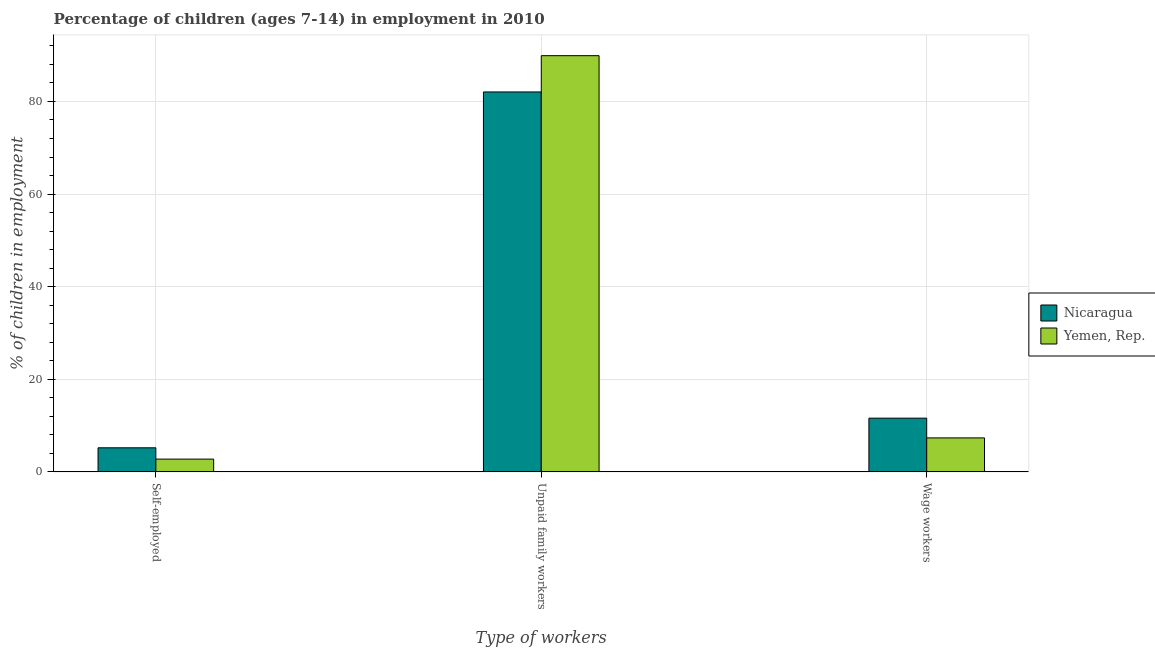How many different coloured bars are there?
Make the answer very short. 2. Are the number of bars per tick equal to the number of legend labels?
Offer a terse response. Yes. Are the number of bars on each tick of the X-axis equal?
Provide a short and direct response. Yes. How many bars are there on the 2nd tick from the left?
Provide a short and direct response. 2. How many bars are there on the 3rd tick from the right?
Offer a terse response. 2. What is the label of the 1st group of bars from the left?
Your answer should be very brief. Self-employed. What is the percentage of children employed as unpaid family workers in Nicaragua?
Your answer should be compact. 82.05. Across all countries, what is the maximum percentage of children employed as wage workers?
Your answer should be compact. 11.61. Across all countries, what is the minimum percentage of children employed as wage workers?
Keep it short and to the point. 7.35. In which country was the percentage of children employed as unpaid family workers maximum?
Offer a very short reply. Yemen, Rep. In which country was the percentage of self employed children minimum?
Make the answer very short. Yemen, Rep. What is the total percentage of children employed as wage workers in the graph?
Your response must be concise. 18.96. What is the difference between the percentage of children employed as unpaid family workers in Nicaragua and that in Yemen, Rep.?
Make the answer very short. -7.83. What is the difference between the percentage of children employed as unpaid family workers in Nicaragua and the percentage of self employed children in Yemen, Rep.?
Offer a very short reply. 79.28. What is the average percentage of self employed children per country?
Provide a short and direct response. 3.99. What is the difference between the percentage of children employed as wage workers and percentage of children employed as unpaid family workers in Nicaragua?
Keep it short and to the point. -70.44. What is the ratio of the percentage of children employed as wage workers in Nicaragua to that in Yemen, Rep.?
Make the answer very short. 1.58. Is the percentage of children employed as unpaid family workers in Nicaragua less than that in Yemen, Rep.?
Your answer should be very brief. Yes. What is the difference between the highest and the second highest percentage of children employed as unpaid family workers?
Make the answer very short. 7.83. What is the difference between the highest and the lowest percentage of children employed as unpaid family workers?
Give a very brief answer. 7.83. Is the sum of the percentage of children employed as wage workers in Yemen, Rep. and Nicaragua greater than the maximum percentage of children employed as unpaid family workers across all countries?
Your answer should be very brief. No. What does the 1st bar from the left in Unpaid family workers represents?
Give a very brief answer. Nicaragua. What does the 1st bar from the right in Wage workers represents?
Your answer should be very brief. Yemen, Rep. Is it the case that in every country, the sum of the percentage of self employed children and percentage of children employed as unpaid family workers is greater than the percentage of children employed as wage workers?
Make the answer very short. Yes. How many bars are there?
Keep it short and to the point. 6. How many countries are there in the graph?
Keep it short and to the point. 2. How are the legend labels stacked?
Make the answer very short. Vertical. What is the title of the graph?
Your answer should be compact. Percentage of children (ages 7-14) in employment in 2010. What is the label or title of the X-axis?
Make the answer very short. Type of workers. What is the label or title of the Y-axis?
Keep it short and to the point. % of children in employment. What is the % of children in employment in Nicaragua in Self-employed?
Your answer should be compact. 5.21. What is the % of children in employment in Yemen, Rep. in Self-employed?
Your answer should be very brief. 2.77. What is the % of children in employment of Nicaragua in Unpaid family workers?
Ensure brevity in your answer.  82.05. What is the % of children in employment in Yemen, Rep. in Unpaid family workers?
Provide a succinct answer. 89.88. What is the % of children in employment in Nicaragua in Wage workers?
Your answer should be compact. 11.61. What is the % of children in employment of Yemen, Rep. in Wage workers?
Offer a terse response. 7.35. Across all Type of workers, what is the maximum % of children in employment of Nicaragua?
Offer a terse response. 82.05. Across all Type of workers, what is the maximum % of children in employment of Yemen, Rep.?
Provide a short and direct response. 89.88. Across all Type of workers, what is the minimum % of children in employment in Nicaragua?
Keep it short and to the point. 5.21. Across all Type of workers, what is the minimum % of children in employment of Yemen, Rep.?
Give a very brief answer. 2.77. What is the total % of children in employment of Nicaragua in the graph?
Keep it short and to the point. 98.87. What is the difference between the % of children in employment of Nicaragua in Self-employed and that in Unpaid family workers?
Keep it short and to the point. -76.84. What is the difference between the % of children in employment in Yemen, Rep. in Self-employed and that in Unpaid family workers?
Make the answer very short. -87.11. What is the difference between the % of children in employment in Yemen, Rep. in Self-employed and that in Wage workers?
Your answer should be compact. -4.58. What is the difference between the % of children in employment of Nicaragua in Unpaid family workers and that in Wage workers?
Give a very brief answer. 70.44. What is the difference between the % of children in employment in Yemen, Rep. in Unpaid family workers and that in Wage workers?
Your answer should be compact. 82.53. What is the difference between the % of children in employment of Nicaragua in Self-employed and the % of children in employment of Yemen, Rep. in Unpaid family workers?
Provide a short and direct response. -84.67. What is the difference between the % of children in employment of Nicaragua in Self-employed and the % of children in employment of Yemen, Rep. in Wage workers?
Provide a short and direct response. -2.14. What is the difference between the % of children in employment in Nicaragua in Unpaid family workers and the % of children in employment in Yemen, Rep. in Wage workers?
Offer a very short reply. 74.7. What is the average % of children in employment in Nicaragua per Type of workers?
Give a very brief answer. 32.96. What is the average % of children in employment of Yemen, Rep. per Type of workers?
Offer a very short reply. 33.33. What is the difference between the % of children in employment in Nicaragua and % of children in employment in Yemen, Rep. in Self-employed?
Give a very brief answer. 2.44. What is the difference between the % of children in employment in Nicaragua and % of children in employment in Yemen, Rep. in Unpaid family workers?
Provide a short and direct response. -7.83. What is the difference between the % of children in employment in Nicaragua and % of children in employment in Yemen, Rep. in Wage workers?
Offer a very short reply. 4.26. What is the ratio of the % of children in employment of Nicaragua in Self-employed to that in Unpaid family workers?
Keep it short and to the point. 0.06. What is the ratio of the % of children in employment of Yemen, Rep. in Self-employed to that in Unpaid family workers?
Your answer should be very brief. 0.03. What is the ratio of the % of children in employment of Nicaragua in Self-employed to that in Wage workers?
Your response must be concise. 0.45. What is the ratio of the % of children in employment in Yemen, Rep. in Self-employed to that in Wage workers?
Offer a very short reply. 0.38. What is the ratio of the % of children in employment of Nicaragua in Unpaid family workers to that in Wage workers?
Your response must be concise. 7.07. What is the ratio of the % of children in employment in Yemen, Rep. in Unpaid family workers to that in Wage workers?
Offer a very short reply. 12.23. What is the difference between the highest and the second highest % of children in employment of Nicaragua?
Offer a terse response. 70.44. What is the difference between the highest and the second highest % of children in employment of Yemen, Rep.?
Your answer should be compact. 82.53. What is the difference between the highest and the lowest % of children in employment in Nicaragua?
Your answer should be compact. 76.84. What is the difference between the highest and the lowest % of children in employment in Yemen, Rep.?
Offer a very short reply. 87.11. 